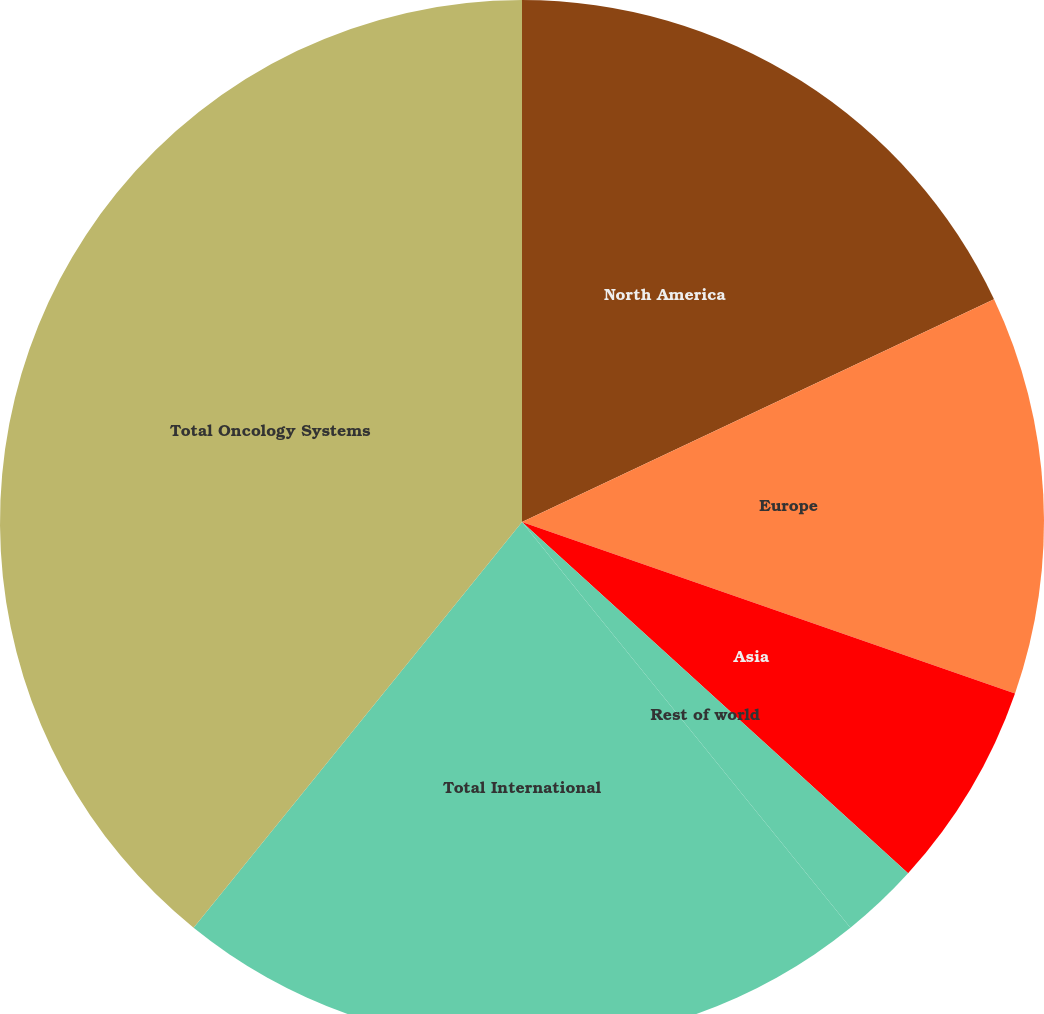Convert chart. <chart><loc_0><loc_0><loc_500><loc_500><pie_chart><fcel>North America<fcel>Europe<fcel>Asia<fcel>Rest of world<fcel>Total International<fcel>Total Oncology Systems<nl><fcel>17.98%<fcel>12.35%<fcel>6.42%<fcel>2.42%<fcel>21.66%<fcel>39.17%<nl></chart> 